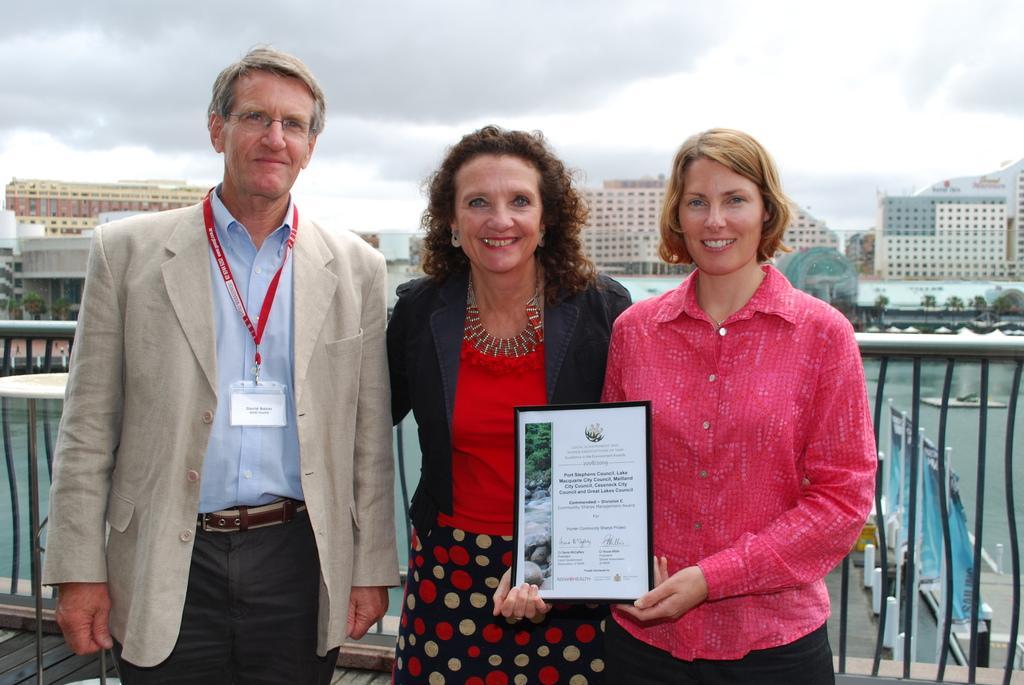Describe this image in one or two sentences. In this image I can see there are three persons, one person holding a frame, visible in front of fence, back side of fence might be the lake and in the middle there are buildings visible, at the top there is the sky visible. 